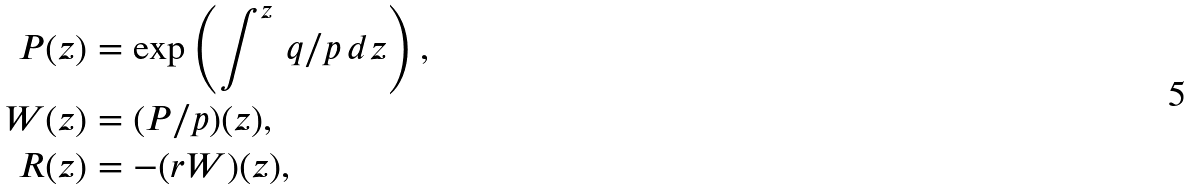Convert formula to latex. <formula><loc_0><loc_0><loc_500><loc_500>P ( z ) & = \exp \left ( \int ^ { z } \, q / p \, d z \right ) , \\ W ( z ) & = ( P / p ) ( z ) , \\ R ( z ) & = - ( r W ) ( z ) ,</formula> 